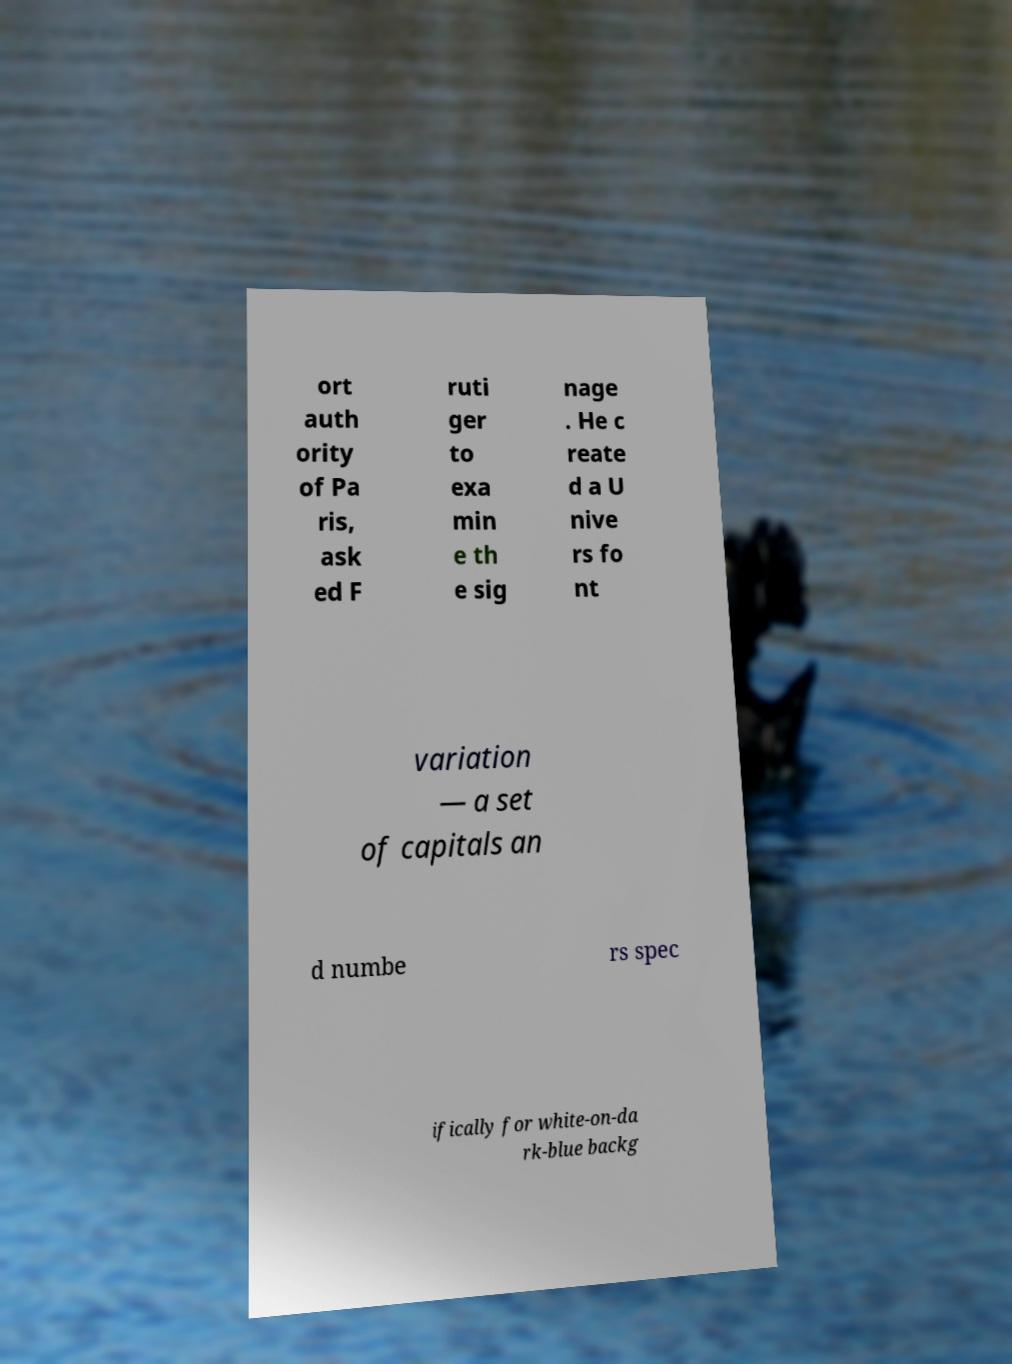Please read and relay the text visible in this image. What does it say? ort auth ority of Pa ris, ask ed F ruti ger to exa min e th e sig nage . He c reate d a U nive rs fo nt variation — a set of capitals an d numbe rs spec ifically for white-on-da rk-blue backg 